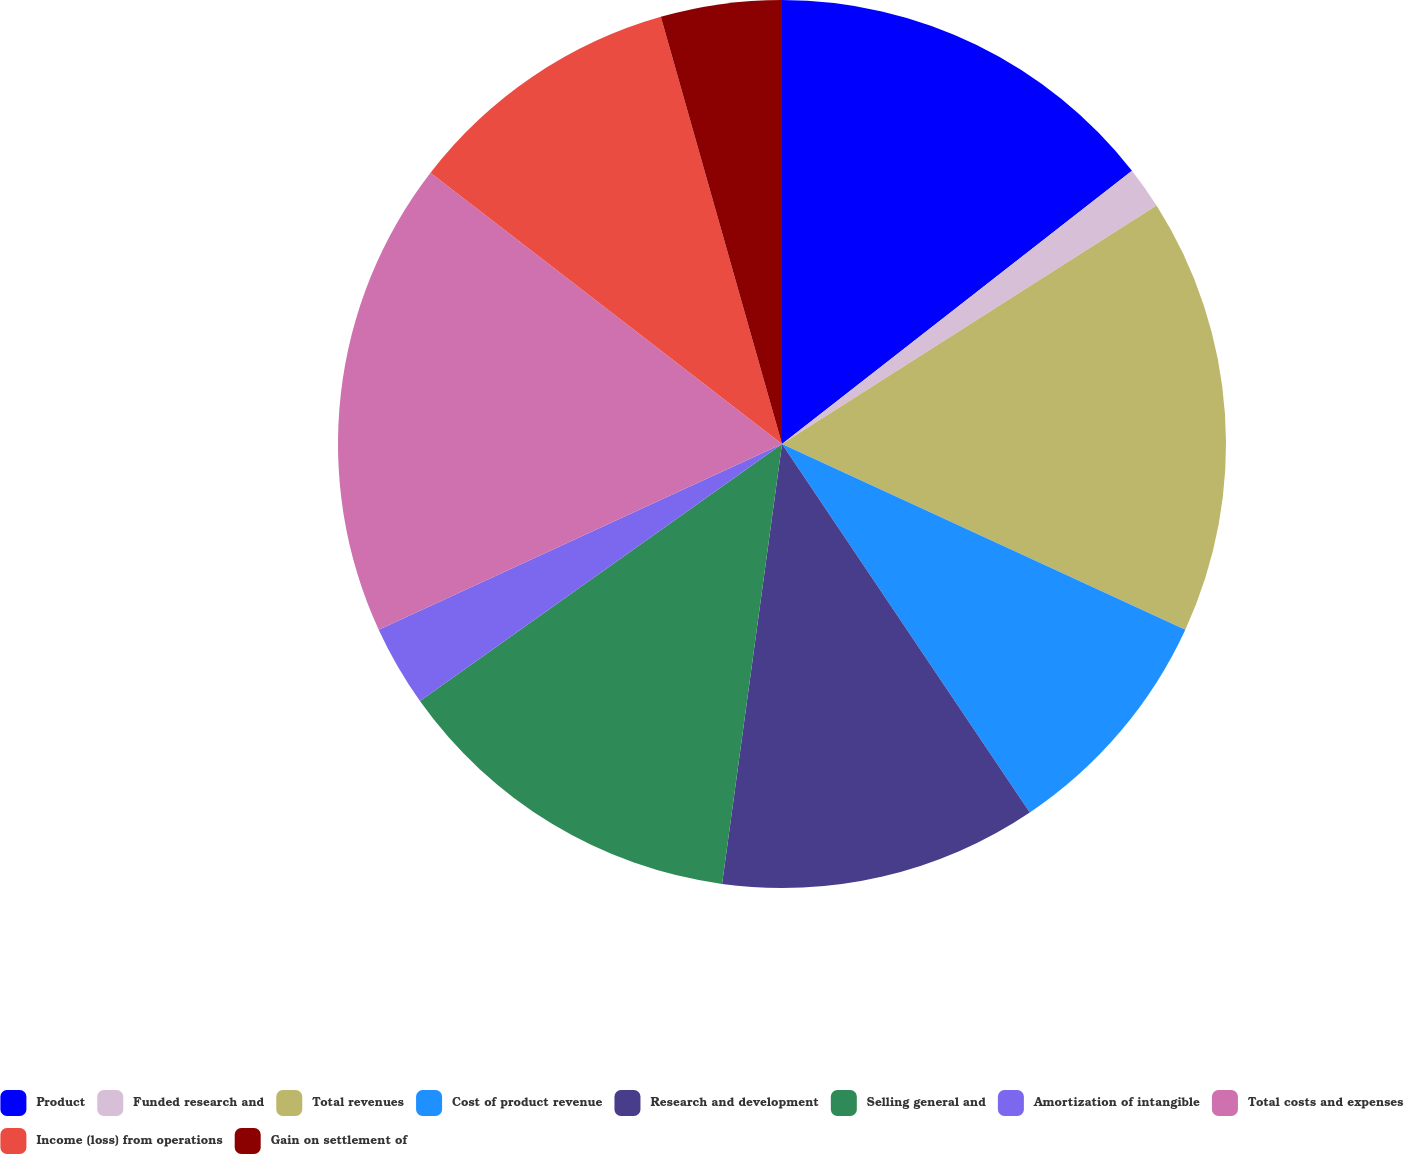Convert chart. <chart><loc_0><loc_0><loc_500><loc_500><pie_chart><fcel>Product<fcel>Funded research and<fcel>Total revenues<fcel>Cost of product revenue<fcel>Research and development<fcel>Selling general and<fcel>Amortization of intangible<fcel>Total costs and expenses<fcel>Income (loss) from operations<fcel>Gain on settlement of<nl><fcel>14.45%<fcel>1.53%<fcel>15.89%<fcel>8.71%<fcel>11.58%<fcel>13.02%<fcel>2.96%<fcel>17.33%<fcel>10.14%<fcel>4.4%<nl></chart> 